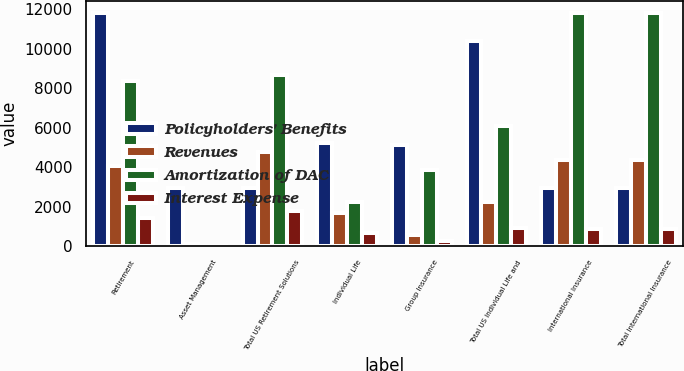<chart> <loc_0><loc_0><loc_500><loc_500><stacked_bar_chart><ecel><fcel>Retirement<fcel>Asset Management<fcel>Total US Retirement Solutions<fcel>Individual Life<fcel>Group Insurance<fcel>Total US Individual Life and<fcel>International Insurance<fcel>Total International Insurance<nl><fcel>Policyholders' Benefits<fcel>11821<fcel>2944<fcel>2944<fcel>5233<fcel>5143<fcel>10376<fcel>2944<fcel>2944<nl><fcel>Revenues<fcel>4082<fcel>111<fcel>4796<fcel>1669<fcel>586<fcel>2255<fcel>4357<fcel>4357<nl><fcel>Amortization of DAC<fcel>8352<fcel>0<fcel>8666<fcel>2245<fcel>3868<fcel>6113<fcel>11821<fcel>11821<nl><fcel>Interest Expense<fcel>1441<fcel>0<fcel>1804<fcel>644<fcel>257<fcel>901<fcel>880<fcel>880<nl></chart> 